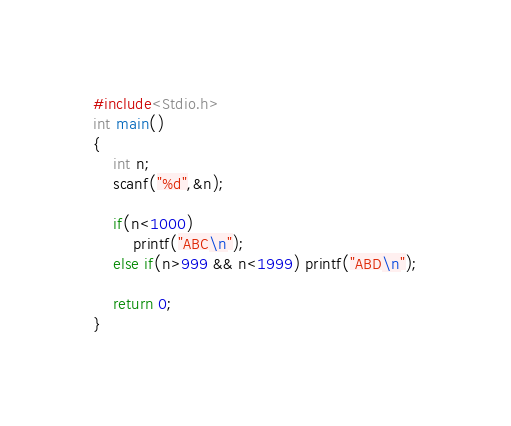Convert code to text. <code><loc_0><loc_0><loc_500><loc_500><_C_>#include<Stdio.h>
int main()
{
    int n;
    scanf("%d",&n);

    if(n<1000)
        printf("ABC\n");
    else if(n>999 && n<1999) printf("ABD\n");

    return 0;
}
</code> 